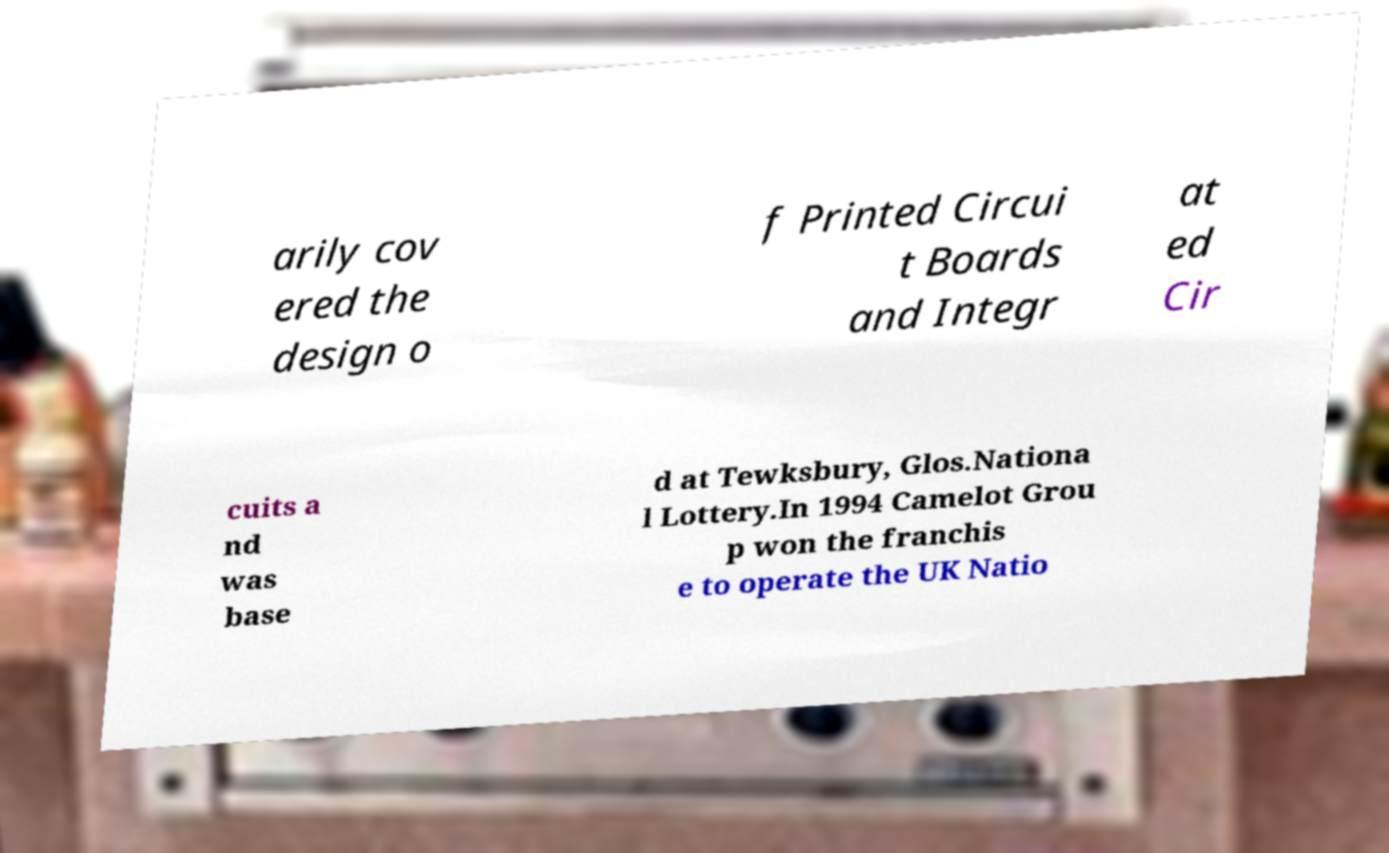I need the written content from this picture converted into text. Can you do that? arily cov ered the design o f Printed Circui t Boards and Integr at ed Cir cuits a nd was base d at Tewksbury, Glos.Nationa l Lottery.In 1994 Camelot Grou p won the franchis e to operate the UK Natio 